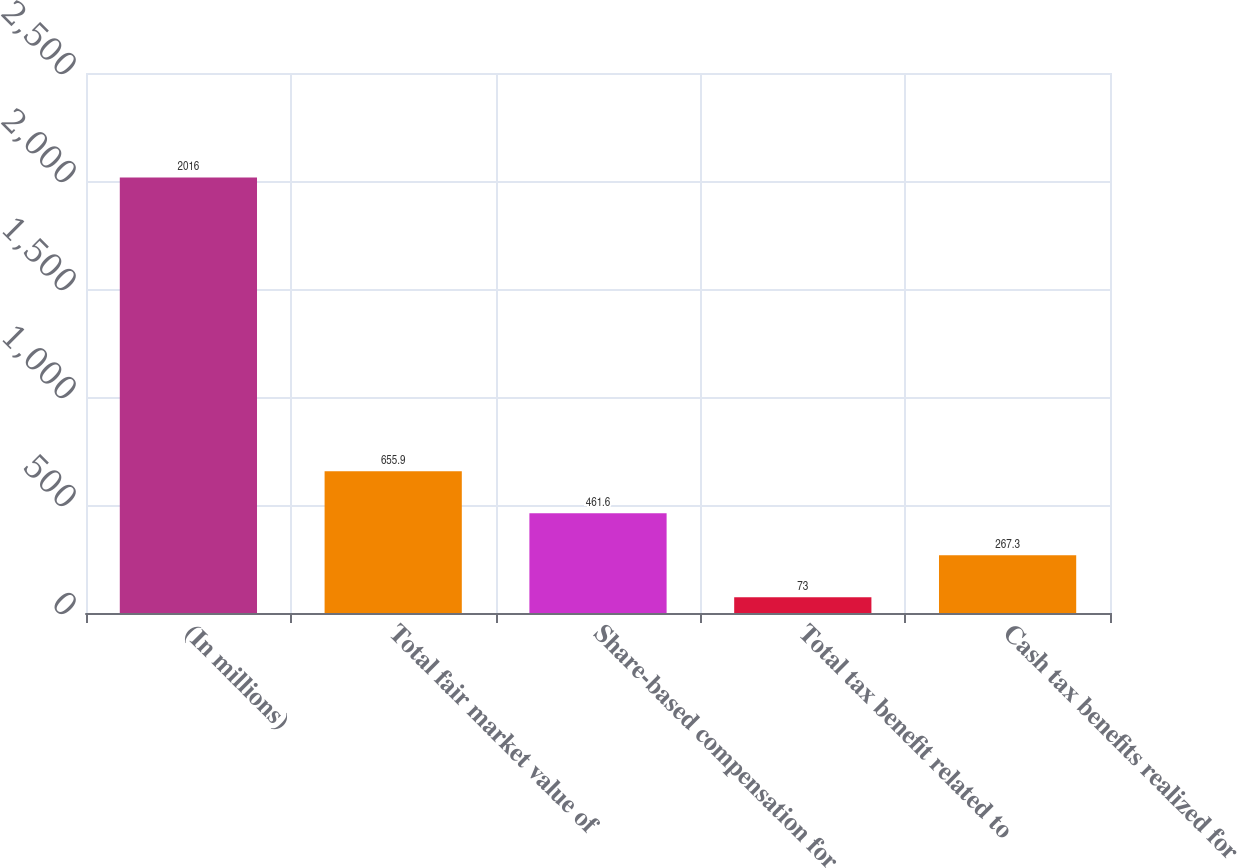Convert chart. <chart><loc_0><loc_0><loc_500><loc_500><bar_chart><fcel>(In millions)<fcel>Total fair market value of<fcel>Share-based compensation for<fcel>Total tax benefit related to<fcel>Cash tax benefits realized for<nl><fcel>2016<fcel>655.9<fcel>461.6<fcel>73<fcel>267.3<nl></chart> 